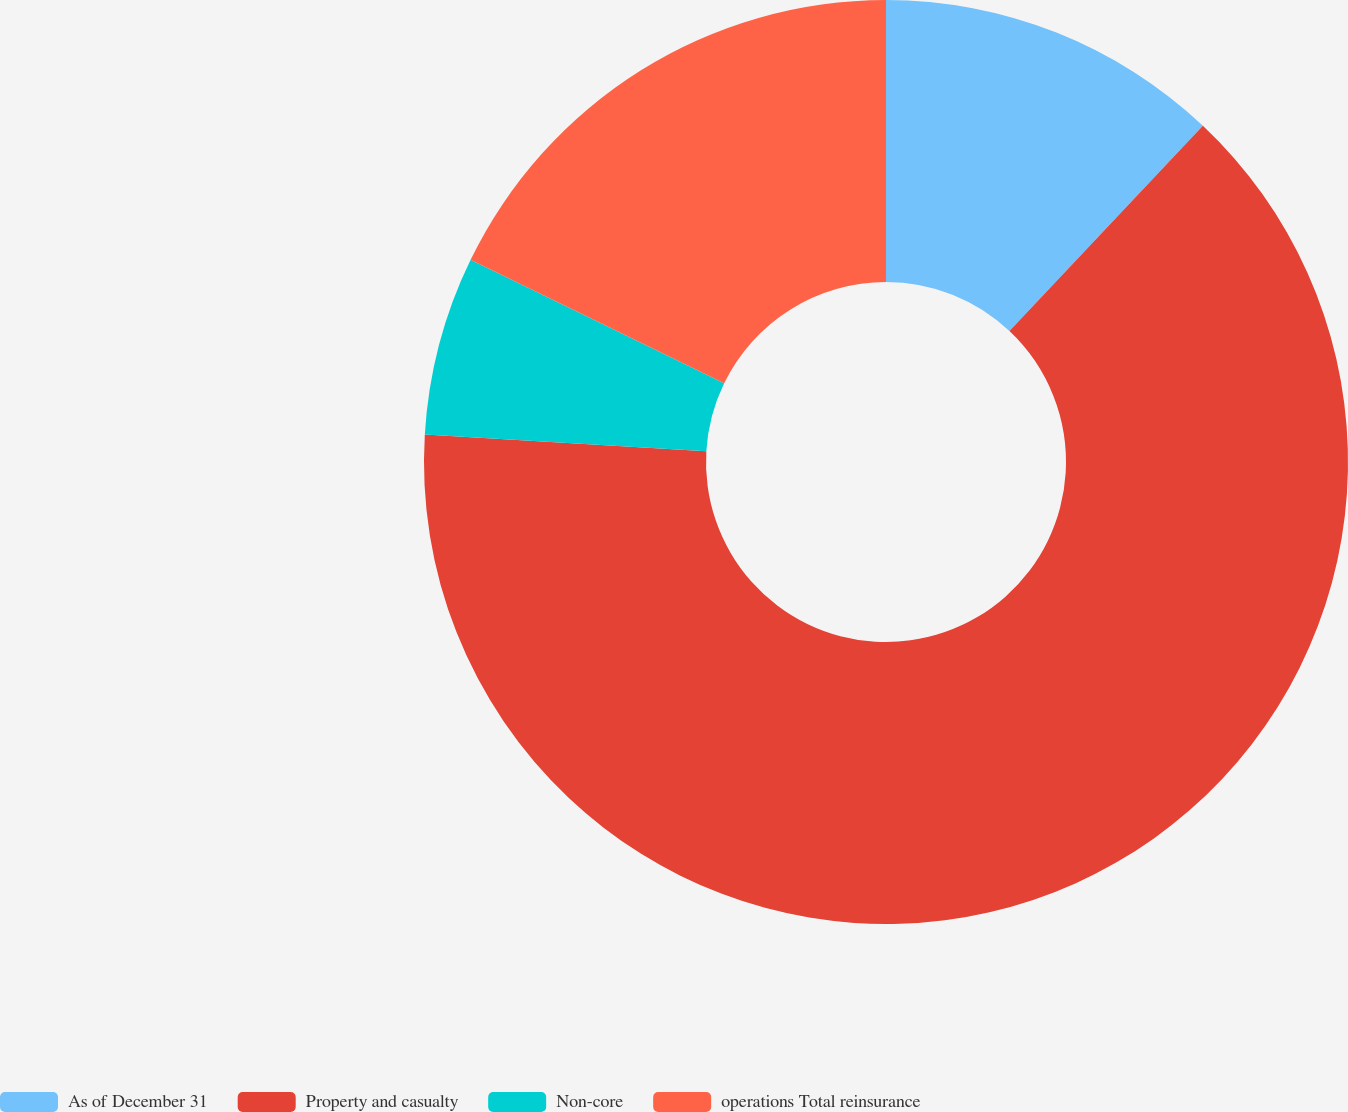Convert chart. <chart><loc_0><loc_0><loc_500><loc_500><pie_chart><fcel>As of December 31<fcel>Property and casualty<fcel>Non-core<fcel>operations Total reinsurance<nl><fcel>12.03%<fcel>63.92%<fcel>6.26%<fcel>17.79%<nl></chart> 